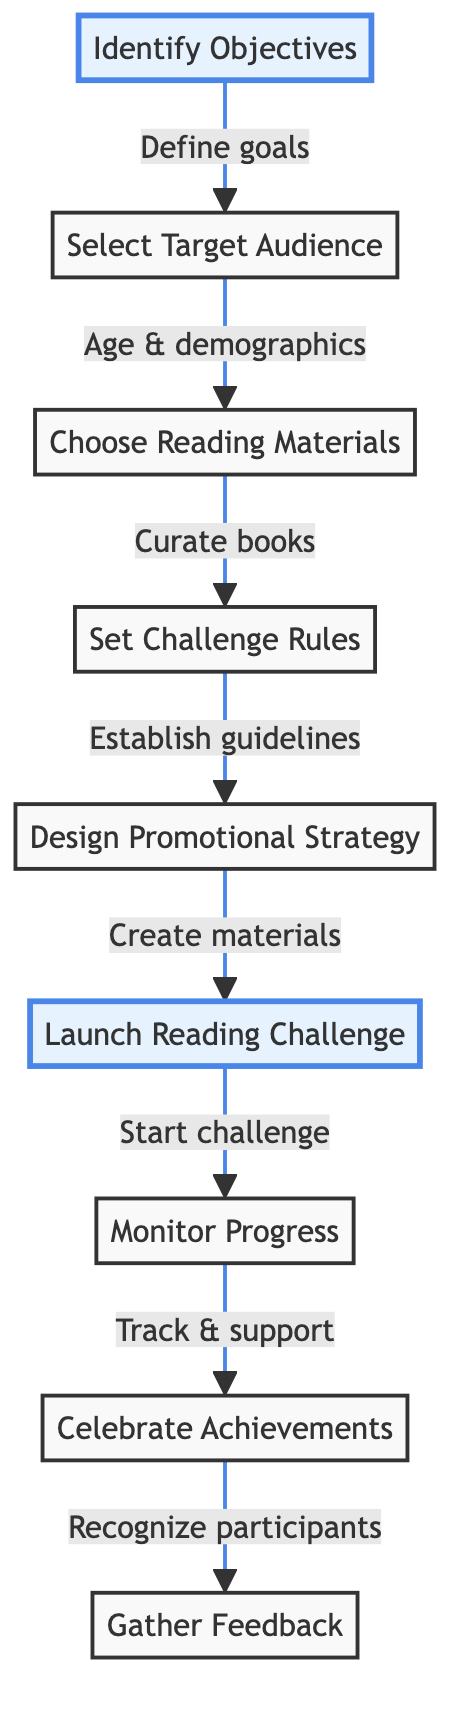What is the first step in the reading challenge process? The diagram starts with the node "Identify Objectives," which outlines the initial step needed for planning the reading challenge.
Answer: Identify Objectives How many total steps are outlined in the diagram? The diagram includes a total of nine distinct nodes, each representing a different step in the reading challenge process.
Answer: Nine Which step follows "Set Challenge Rules"? According to the flow of the diagram, the step that follows "Set Challenge Rules" is "Design Promotional Strategy." This shows the sequence of actions to be taken.
Answer: Design Promotional Strategy What does the "Launch Reading Challenge" step emphasize? The "Launch Reading Challenge" step highlights the action of officially starting the challenge, which indicates that all preparations are complete and the participants can begin.
Answer: Start challenge What is the final action to be taken after "Celebrate Achievements"? After "Celebrate Achievements," the next action is to "Gather Feedback," indicating that the process includes evaluating the event to improve future iterations.
Answer: Gather Feedback How are the objectives defined in the process flow? The flow chart shows that objectives are defined by first identifying them in the "Identify Objectives" step, leading to selecting the target audience in the sequential process.
Answer: Define goals What does the "Monitor Progress" step entail? The "Monitor Progress" step involves tracking participants' reading activities and providing necessary support throughout the challenge, ensuring participants stay engaged and on track.
Answer: Track & support Which two steps connect "Choose Reading Materials" to "Set Challenge Rules"? "Choose Reading Materials" connects to "Set Challenge Rules" directly, illustrating the flow from selecting books to establishing guidelines necessary for participation.
Answer: Curate books, Establish guidelines What role does the "Design Promotional Strategy" play in the challenge? The "Design Promotional Strategy" step is crucial for creating engagement and awareness about the challenge, as it involves creating promotional materials to attract participants.
Answer: Create materials 